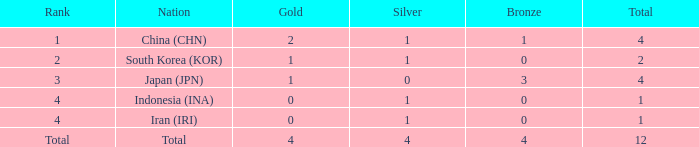How many silver medals for the nation with fewer than 1 golds and total less than 1? 0.0. 